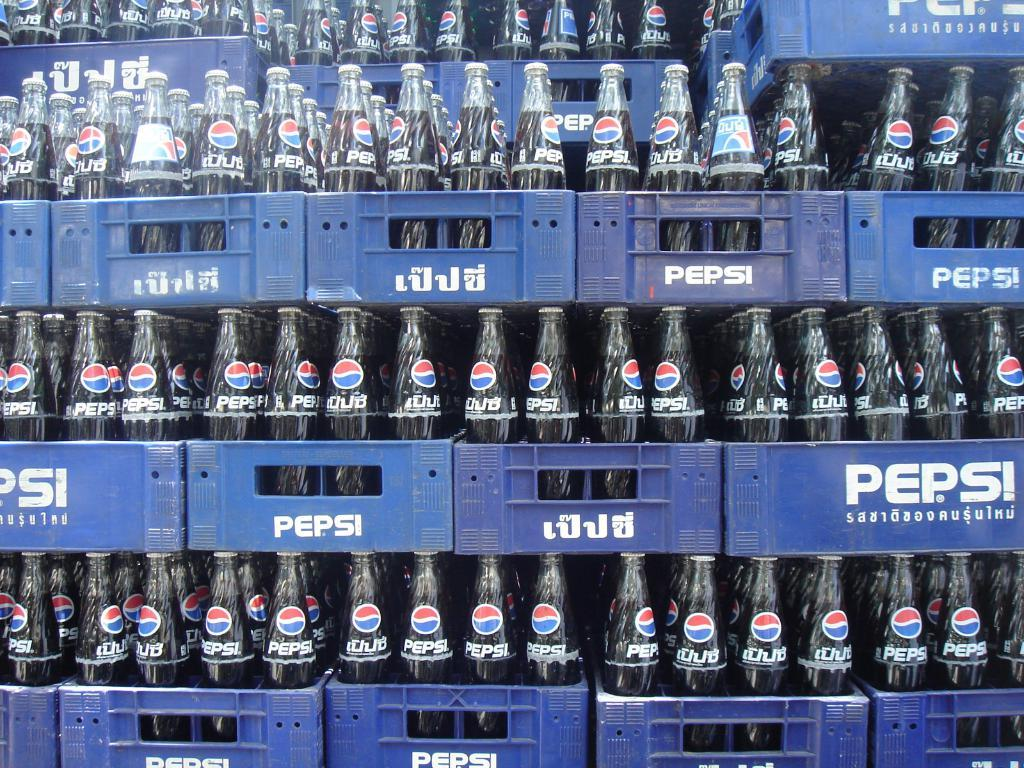<image>
Describe the image concisely. rows of blue plastic crates full of glass pepsi bottles 